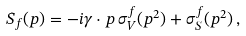Convert formula to latex. <formula><loc_0><loc_0><loc_500><loc_500>S _ { f } ( p ) = - i \gamma \cdot p \, \sigma _ { V } ^ { f } ( p ^ { 2 } ) + \sigma _ { S } ^ { f } ( p ^ { 2 } ) \, ,</formula> 